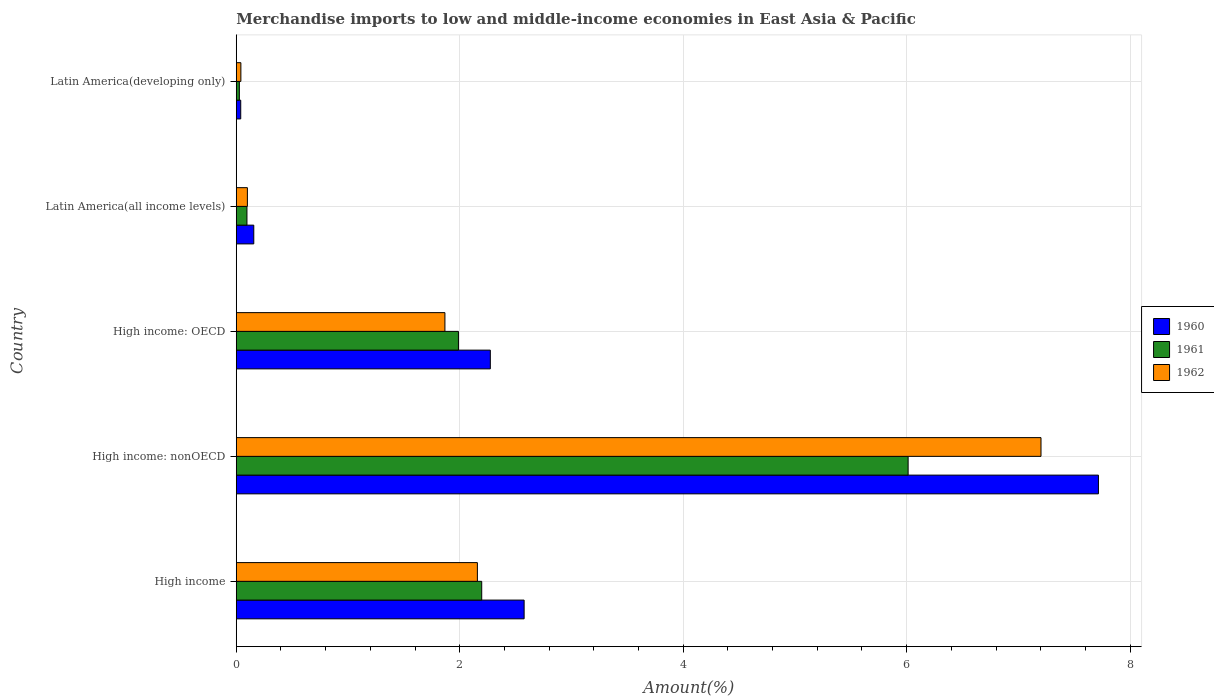How many different coloured bars are there?
Your answer should be very brief. 3. How many bars are there on the 3rd tick from the bottom?
Offer a very short reply. 3. What is the label of the 2nd group of bars from the top?
Offer a very short reply. Latin America(all income levels). What is the percentage of amount earned from merchandise imports in 1961 in High income?
Your response must be concise. 2.2. Across all countries, what is the maximum percentage of amount earned from merchandise imports in 1961?
Your response must be concise. 6.01. Across all countries, what is the minimum percentage of amount earned from merchandise imports in 1962?
Provide a succinct answer. 0.04. In which country was the percentage of amount earned from merchandise imports in 1960 maximum?
Provide a succinct answer. High income: nonOECD. In which country was the percentage of amount earned from merchandise imports in 1960 minimum?
Your answer should be compact. Latin America(developing only). What is the total percentage of amount earned from merchandise imports in 1960 in the graph?
Keep it short and to the point. 12.76. What is the difference between the percentage of amount earned from merchandise imports in 1962 in High income: nonOECD and that in Latin America(developing only)?
Your response must be concise. 7.16. What is the difference between the percentage of amount earned from merchandise imports in 1961 in High income: OECD and the percentage of amount earned from merchandise imports in 1960 in Latin America(developing only)?
Keep it short and to the point. 1.95. What is the average percentage of amount earned from merchandise imports in 1961 per country?
Give a very brief answer. 2.06. What is the difference between the percentage of amount earned from merchandise imports in 1962 and percentage of amount earned from merchandise imports in 1960 in High income: OECD?
Provide a short and direct response. -0.41. What is the ratio of the percentage of amount earned from merchandise imports in 1962 in High income: OECD to that in High income: nonOECD?
Ensure brevity in your answer.  0.26. Is the percentage of amount earned from merchandise imports in 1962 in High income: nonOECD less than that in Latin America(all income levels)?
Your response must be concise. No. What is the difference between the highest and the second highest percentage of amount earned from merchandise imports in 1962?
Ensure brevity in your answer.  5.04. What is the difference between the highest and the lowest percentage of amount earned from merchandise imports in 1962?
Make the answer very short. 7.16. What does the 3rd bar from the top in High income: OECD represents?
Keep it short and to the point. 1960. What is the difference between two consecutive major ticks on the X-axis?
Offer a terse response. 2. Are the values on the major ticks of X-axis written in scientific E-notation?
Give a very brief answer. No. How many legend labels are there?
Offer a very short reply. 3. How are the legend labels stacked?
Your answer should be compact. Vertical. What is the title of the graph?
Keep it short and to the point. Merchandise imports to low and middle-income economies in East Asia & Pacific. What is the label or title of the X-axis?
Your answer should be compact. Amount(%). What is the Amount(%) in 1960 in High income?
Keep it short and to the point. 2.58. What is the Amount(%) of 1961 in High income?
Your answer should be compact. 2.2. What is the Amount(%) of 1962 in High income?
Give a very brief answer. 2.16. What is the Amount(%) in 1960 in High income: nonOECD?
Offer a very short reply. 7.72. What is the Amount(%) of 1961 in High income: nonOECD?
Give a very brief answer. 6.01. What is the Amount(%) of 1962 in High income: nonOECD?
Make the answer very short. 7.2. What is the Amount(%) in 1960 in High income: OECD?
Your answer should be very brief. 2.27. What is the Amount(%) in 1961 in High income: OECD?
Ensure brevity in your answer.  1.99. What is the Amount(%) of 1962 in High income: OECD?
Provide a short and direct response. 1.87. What is the Amount(%) in 1960 in Latin America(all income levels)?
Provide a succinct answer. 0.16. What is the Amount(%) of 1961 in Latin America(all income levels)?
Give a very brief answer. 0.1. What is the Amount(%) in 1962 in Latin America(all income levels)?
Ensure brevity in your answer.  0.1. What is the Amount(%) of 1960 in Latin America(developing only)?
Provide a succinct answer. 0.04. What is the Amount(%) of 1961 in Latin America(developing only)?
Make the answer very short. 0.03. What is the Amount(%) in 1962 in Latin America(developing only)?
Offer a terse response. 0.04. Across all countries, what is the maximum Amount(%) of 1960?
Ensure brevity in your answer.  7.72. Across all countries, what is the maximum Amount(%) of 1961?
Make the answer very short. 6.01. Across all countries, what is the maximum Amount(%) in 1962?
Your response must be concise. 7.2. Across all countries, what is the minimum Amount(%) in 1960?
Offer a very short reply. 0.04. Across all countries, what is the minimum Amount(%) of 1961?
Give a very brief answer. 0.03. Across all countries, what is the minimum Amount(%) in 1962?
Ensure brevity in your answer.  0.04. What is the total Amount(%) of 1960 in the graph?
Give a very brief answer. 12.76. What is the total Amount(%) of 1961 in the graph?
Provide a succinct answer. 10.32. What is the total Amount(%) in 1962 in the graph?
Ensure brevity in your answer.  11.37. What is the difference between the Amount(%) of 1960 in High income and that in High income: nonOECD?
Provide a short and direct response. -5.14. What is the difference between the Amount(%) of 1961 in High income and that in High income: nonOECD?
Your response must be concise. -3.82. What is the difference between the Amount(%) of 1962 in High income and that in High income: nonOECD?
Keep it short and to the point. -5.04. What is the difference between the Amount(%) of 1960 in High income and that in High income: OECD?
Give a very brief answer. 0.3. What is the difference between the Amount(%) in 1961 in High income and that in High income: OECD?
Offer a very short reply. 0.21. What is the difference between the Amount(%) of 1962 in High income and that in High income: OECD?
Make the answer very short. 0.29. What is the difference between the Amount(%) in 1960 in High income and that in Latin America(all income levels)?
Provide a short and direct response. 2.42. What is the difference between the Amount(%) of 1961 in High income and that in Latin America(all income levels)?
Your answer should be very brief. 2.1. What is the difference between the Amount(%) in 1962 in High income and that in Latin America(all income levels)?
Offer a very short reply. 2.06. What is the difference between the Amount(%) of 1960 in High income and that in Latin America(developing only)?
Keep it short and to the point. 2.54. What is the difference between the Amount(%) of 1961 in High income and that in Latin America(developing only)?
Offer a very short reply. 2.17. What is the difference between the Amount(%) in 1962 in High income and that in Latin America(developing only)?
Provide a short and direct response. 2.12. What is the difference between the Amount(%) in 1960 in High income: nonOECD and that in High income: OECD?
Provide a short and direct response. 5.44. What is the difference between the Amount(%) of 1961 in High income: nonOECD and that in High income: OECD?
Provide a succinct answer. 4.02. What is the difference between the Amount(%) of 1962 in High income: nonOECD and that in High income: OECD?
Give a very brief answer. 5.33. What is the difference between the Amount(%) of 1960 in High income: nonOECD and that in Latin America(all income levels)?
Offer a very short reply. 7.56. What is the difference between the Amount(%) in 1961 in High income: nonOECD and that in Latin America(all income levels)?
Offer a terse response. 5.92. What is the difference between the Amount(%) of 1962 in High income: nonOECD and that in Latin America(all income levels)?
Offer a terse response. 7.1. What is the difference between the Amount(%) of 1960 in High income: nonOECD and that in Latin America(developing only)?
Your answer should be very brief. 7.68. What is the difference between the Amount(%) of 1961 in High income: nonOECD and that in Latin America(developing only)?
Keep it short and to the point. 5.99. What is the difference between the Amount(%) in 1962 in High income: nonOECD and that in Latin America(developing only)?
Your answer should be very brief. 7.16. What is the difference between the Amount(%) of 1960 in High income: OECD and that in Latin America(all income levels)?
Your answer should be very brief. 2.12. What is the difference between the Amount(%) in 1961 in High income: OECD and that in Latin America(all income levels)?
Make the answer very short. 1.89. What is the difference between the Amount(%) in 1962 in High income: OECD and that in Latin America(all income levels)?
Offer a terse response. 1.77. What is the difference between the Amount(%) of 1960 in High income: OECD and that in Latin America(developing only)?
Your answer should be compact. 2.23. What is the difference between the Amount(%) of 1961 in High income: OECD and that in Latin America(developing only)?
Your response must be concise. 1.96. What is the difference between the Amount(%) of 1962 in High income: OECD and that in Latin America(developing only)?
Give a very brief answer. 1.83. What is the difference between the Amount(%) in 1960 in Latin America(all income levels) and that in Latin America(developing only)?
Provide a succinct answer. 0.12. What is the difference between the Amount(%) in 1961 in Latin America(all income levels) and that in Latin America(developing only)?
Offer a terse response. 0.07. What is the difference between the Amount(%) in 1962 in Latin America(all income levels) and that in Latin America(developing only)?
Give a very brief answer. 0.06. What is the difference between the Amount(%) in 1960 in High income and the Amount(%) in 1961 in High income: nonOECD?
Keep it short and to the point. -3.44. What is the difference between the Amount(%) of 1960 in High income and the Amount(%) of 1962 in High income: nonOECD?
Your response must be concise. -4.63. What is the difference between the Amount(%) in 1961 in High income and the Amount(%) in 1962 in High income: nonOECD?
Provide a short and direct response. -5.01. What is the difference between the Amount(%) in 1960 in High income and the Amount(%) in 1961 in High income: OECD?
Offer a terse response. 0.59. What is the difference between the Amount(%) of 1960 in High income and the Amount(%) of 1962 in High income: OECD?
Your response must be concise. 0.71. What is the difference between the Amount(%) in 1961 in High income and the Amount(%) in 1962 in High income: OECD?
Keep it short and to the point. 0.33. What is the difference between the Amount(%) of 1960 in High income and the Amount(%) of 1961 in Latin America(all income levels)?
Your response must be concise. 2.48. What is the difference between the Amount(%) of 1960 in High income and the Amount(%) of 1962 in Latin America(all income levels)?
Make the answer very short. 2.48. What is the difference between the Amount(%) in 1961 in High income and the Amount(%) in 1962 in Latin America(all income levels)?
Offer a terse response. 2.1. What is the difference between the Amount(%) of 1960 in High income and the Amount(%) of 1961 in Latin America(developing only)?
Ensure brevity in your answer.  2.55. What is the difference between the Amount(%) of 1960 in High income and the Amount(%) of 1962 in Latin America(developing only)?
Offer a very short reply. 2.54. What is the difference between the Amount(%) of 1961 in High income and the Amount(%) of 1962 in Latin America(developing only)?
Give a very brief answer. 2.16. What is the difference between the Amount(%) in 1960 in High income: nonOECD and the Amount(%) in 1961 in High income: OECD?
Your answer should be compact. 5.73. What is the difference between the Amount(%) of 1960 in High income: nonOECD and the Amount(%) of 1962 in High income: OECD?
Provide a succinct answer. 5.85. What is the difference between the Amount(%) in 1961 in High income: nonOECD and the Amount(%) in 1962 in High income: OECD?
Offer a terse response. 4.15. What is the difference between the Amount(%) of 1960 in High income: nonOECD and the Amount(%) of 1961 in Latin America(all income levels)?
Give a very brief answer. 7.62. What is the difference between the Amount(%) in 1960 in High income: nonOECD and the Amount(%) in 1962 in Latin America(all income levels)?
Your answer should be very brief. 7.62. What is the difference between the Amount(%) in 1961 in High income: nonOECD and the Amount(%) in 1962 in Latin America(all income levels)?
Your answer should be very brief. 5.91. What is the difference between the Amount(%) of 1960 in High income: nonOECD and the Amount(%) of 1961 in Latin America(developing only)?
Give a very brief answer. 7.69. What is the difference between the Amount(%) in 1960 in High income: nonOECD and the Amount(%) in 1962 in Latin America(developing only)?
Provide a short and direct response. 7.67. What is the difference between the Amount(%) in 1961 in High income: nonOECD and the Amount(%) in 1962 in Latin America(developing only)?
Offer a very short reply. 5.97. What is the difference between the Amount(%) of 1960 in High income: OECD and the Amount(%) of 1961 in Latin America(all income levels)?
Offer a very short reply. 2.18. What is the difference between the Amount(%) of 1960 in High income: OECD and the Amount(%) of 1962 in Latin America(all income levels)?
Give a very brief answer. 2.17. What is the difference between the Amount(%) of 1961 in High income: OECD and the Amount(%) of 1962 in Latin America(all income levels)?
Offer a very short reply. 1.89. What is the difference between the Amount(%) in 1960 in High income: OECD and the Amount(%) in 1961 in Latin America(developing only)?
Provide a succinct answer. 2.25. What is the difference between the Amount(%) in 1960 in High income: OECD and the Amount(%) in 1962 in Latin America(developing only)?
Your answer should be very brief. 2.23. What is the difference between the Amount(%) of 1961 in High income: OECD and the Amount(%) of 1962 in Latin America(developing only)?
Make the answer very short. 1.95. What is the difference between the Amount(%) of 1960 in Latin America(all income levels) and the Amount(%) of 1961 in Latin America(developing only)?
Give a very brief answer. 0.13. What is the difference between the Amount(%) of 1960 in Latin America(all income levels) and the Amount(%) of 1962 in Latin America(developing only)?
Ensure brevity in your answer.  0.12. What is the difference between the Amount(%) of 1961 in Latin America(all income levels) and the Amount(%) of 1962 in Latin America(developing only)?
Give a very brief answer. 0.05. What is the average Amount(%) in 1960 per country?
Give a very brief answer. 2.55. What is the average Amount(%) of 1961 per country?
Your answer should be compact. 2.06. What is the average Amount(%) in 1962 per country?
Keep it short and to the point. 2.27. What is the difference between the Amount(%) of 1960 and Amount(%) of 1961 in High income?
Offer a terse response. 0.38. What is the difference between the Amount(%) in 1960 and Amount(%) in 1962 in High income?
Make the answer very short. 0.42. What is the difference between the Amount(%) in 1961 and Amount(%) in 1962 in High income?
Offer a very short reply. 0.04. What is the difference between the Amount(%) of 1960 and Amount(%) of 1961 in High income: nonOECD?
Make the answer very short. 1.7. What is the difference between the Amount(%) in 1960 and Amount(%) in 1962 in High income: nonOECD?
Provide a succinct answer. 0.51. What is the difference between the Amount(%) of 1961 and Amount(%) of 1962 in High income: nonOECD?
Ensure brevity in your answer.  -1.19. What is the difference between the Amount(%) of 1960 and Amount(%) of 1961 in High income: OECD?
Offer a terse response. 0.29. What is the difference between the Amount(%) of 1960 and Amount(%) of 1962 in High income: OECD?
Ensure brevity in your answer.  0.41. What is the difference between the Amount(%) in 1961 and Amount(%) in 1962 in High income: OECD?
Keep it short and to the point. 0.12. What is the difference between the Amount(%) in 1960 and Amount(%) in 1961 in Latin America(all income levels)?
Your answer should be compact. 0.06. What is the difference between the Amount(%) in 1960 and Amount(%) in 1962 in Latin America(all income levels)?
Give a very brief answer. 0.06. What is the difference between the Amount(%) of 1961 and Amount(%) of 1962 in Latin America(all income levels)?
Ensure brevity in your answer.  -0. What is the difference between the Amount(%) of 1960 and Amount(%) of 1961 in Latin America(developing only)?
Keep it short and to the point. 0.01. What is the difference between the Amount(%) of 1960 and Amount(%) of 1962 in Latin America(developing only)?
Your answer should be compact. -0. What is the difference between the Amount(%) in 1961 and Amount(%) in 1962 in Latin America(developing only)?
Make the answer very short. -0.01. What is the ratio of the Amount(%) in 1960 in High income to that in High income: nonOECD?
Your response must be concise. 0.33. What is the ratio of the Amount(%) of 1961 in High income to that in High income: nonOECD?
Keep it short and to the point. 0.37. What is the ratio of the Amount(%) of 1962 in High income to that in High income: nonOECD?
Your response must be concise. 0.3. What is the ratio of the Amount(%) of 1960 in High income to that in High income: OECD?
Ensure brevity in your answer.  1.13. What is the ratio of the Amount(%) in 1961 in High income to that in High income: OECD?
Give a very brief answer. 1.1. What is the ratio of the Amount(%) of 1962 in High income to that in High income: OECD?
Offer a terse response. 1.16. What is the ratio of the Amount(%) of 1960 in High income to that in Latin America(all income levels)?
Your response must be concise. 16.42. What is the ratio of the Amount(%) of 1961 in High income to that in Latin America(all income levels)?
Your response must be concise. 22.93. What is the ratio of the Amount(%) in 1962 in High income to that in Latin America(all income levels)?
Your answer should be very brief. 21.66. What is the ratio of the Amount(%) in 1960 in High income to that in Latin America(developing only)?
Offer a very short reply. 64.25. What is the ratio of the Amount(%) in 1961 in High income to that in Latin America(developing only)?
Make the answer very short. 79.06. What is the ratio of the Amount(%) of 1962 in High income to that in Latin America(developing only)?
Your answer should be compact. 52.23. What is the ratio of the Amount(%) in 1960 in High income: nonOECD to that in High income: OECD?
Provide a succinct answer. 3.39. What is the ratio of the Amount(%) in 1961 in High income: nonOECD to that in High income: OECD?
Your answer should be very brief. 3.02. What is the ratio of the Amount(%) in 1962 in High income: nonOECD to that in High income: OECD?
Provide a succinct answer. 3.86. What is the ratio of the Amount(%) of 1960 in High income: nonOECD to that in Latin America(all income levels)?
Your answer should be compact. 49.18. What is the ratio of the Amount(%) in 1961 in High income: nonOECD to that in Latin America(all income levels)?
Provide a short and direct response. 62.77. What is the ratio of the Amount(%) of 1962 in High income: nonOECD to that in Latin America(all income levels)?
Keep it short and to the point. 72.3. What is the ratio of the Amount(%) in 1960 in High income: nonOECD to that in Latin America(developing only)?
Your answer should be compact. 192.42. What is the ratio of the Amount(%) in 1961 in High income: nonOECD to that in Latin America(developing only)?
Provide a short and direct response. 216.41. What is the ratio of the Amount(%) of 1962 in High income: nonOECD to that in Latin America(developing only)?
Provide a succinct answer. 174.29. What is the ratio of the Amount(%) of 1960 in High income: OECD to that in Latin America(all income levels)?
Provide a succinct answer. 14.49. What is the ratio of the Amount(%) of 1961 in High income: OECD to that in Latin America(all income levels)?
Ensure brevity in your answer.  20.76. What is the ratio of the Amount(%) of 1962 in High income: OECD to that in Latin America(all income levels)?
Make the answer very short. 18.75. What is the ratio of the Amount(%) of 1960 in High income: OECD to that in Latin America(developing only)?
Make the answer very short. 56.7. What is the ratio of the Amount(%) in 1961 in High income: OECD to that in Latin America(developing only)?
Your answer should be compact. 71.56. What is the ratio of the Amount(%) in 1962 in High income: OECD to that in Latin America(developing only)?
Provide a short and direct response. 45.19. What is the ratio of the Amount(%) of 1960 in Latin America(all income levels) to that in Latin America(developing only)?
Offer a terse response. 3.91. What is the ratio of the Amount(%) in 1961 in Latin America(all income levels) to that in Latin America(developing only)?
Your answer should be very brief. 3.45. What is the ratio of the Amount(%) in 1962 in Latin America(all income levels) to that in Latin America(developing only)?
Offer a terse response. 2.41. What is the difference between the highest and the second highest Amount(%) in 1960?
Your answer should be compact. 5.14. What is the difference between the highest and the second highest Amount(%) in 1961?
Keep it short and to the point. 3.82. What is the difference between the highest and the second highest Amount(%) of 1962?
Keep it short and to the point. 5.04. What is the difference between the highest and the lowest Amount(%) of 1960?
Provide a succinct answer. 7.68. What is the difference between the highest and the lowest Amount(%) of 1961?
Your response must be concise. 5.99. What is the difference between the highest and the lowest Amount(%) in 1962?
Provide a succinct answer. 7.16. 